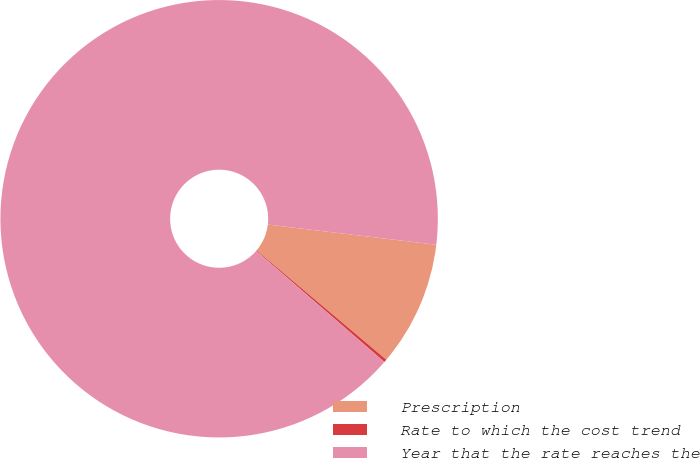<chart> <loc_0><loc_0><loc_500><loc_500><pie_chart><fcel>Prescription<fcel>Rate to which the cost trend<fcel>Year that the rate reaches the<nl><fcel>9.25%<fcel>0.22%<fcel>90.52%<nl></chart> 